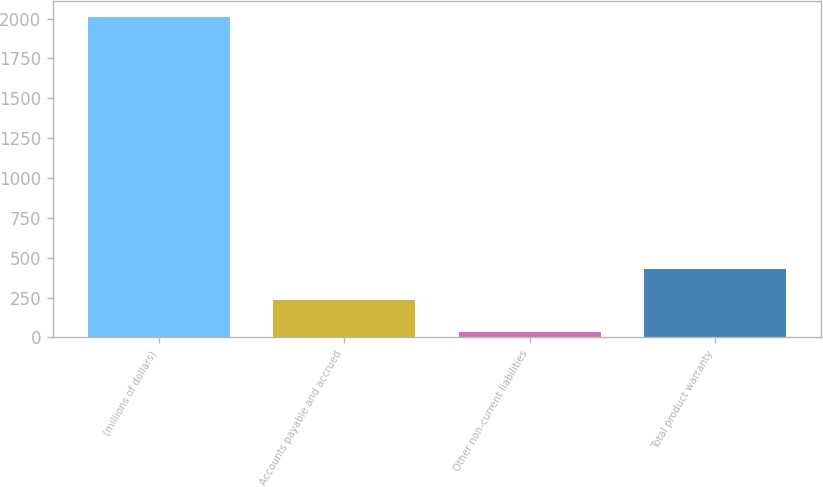Convert chart. <chart><loc_0><loc_0><loc_500><loc_500><bar_chart><fcel>(millions of dollars)<fcel>Accounts payable and accrued<fcel>Other non-current liabilities<fcel>Total product warranty<nl><fcel>2011<fcel>231.79<fcel>34.1<fcel>429.48<nl></chart> 